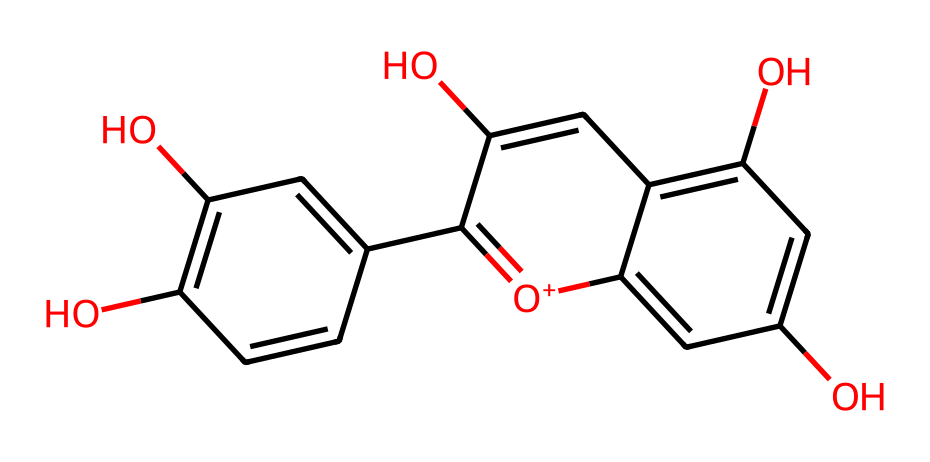What is the main type of pigment represented by this SMILES structure? The SMILES indicates the presence of hydroxyl groups and a significant aromatic structure, characteristic of anthocyanins, which are known plant pigments responsible for red, purple, and blue colors in flowers and fruits.
Answer: anthocyanin How many hydroxyl (-OH) groups are present in this chemical? By analyzing the structure, there are four -OH groups indicated directly by their presence connected to different carbon atoms in the ring structure of anthocyanin.
Answer: four What is the total number of carbon atoms in this chemical? Investigating the provided SMILES shows multiple carbon atoms connected in rings and branches. Counting yields a total of fifteen carbon atoms.
Answer: fifteen Given this structure belongs to a dye, what kind of color does it likely produce in fabrics? Anthocyanins typically yield shades of purple, red, or blue depending on pH and other factors, which is consistent with the color seen in purple jerseys.
Answer: purple What element is responsible for the positive charge in this structure? The presence of an oxygen atom with a positive charge, depicted as [O+], indicates that this specific atom is responsible for the positive charge in the molecule.
Answer: oxygen Are there any double bonds present in this chemical? The structure contains several instances of carbon-carbon double bonds in the aromatic rings, indicating the presence of unsaturation within the molecule.
Answer: yes What is the probable impact of the -OH groups on the solubility of the dye in water? The -OH groups enhance the polarity of the molecule, increasing its hydrogen bonding capacity with water, thus indicating that the dye is likely to be water-soluble.
Answer: soluble 